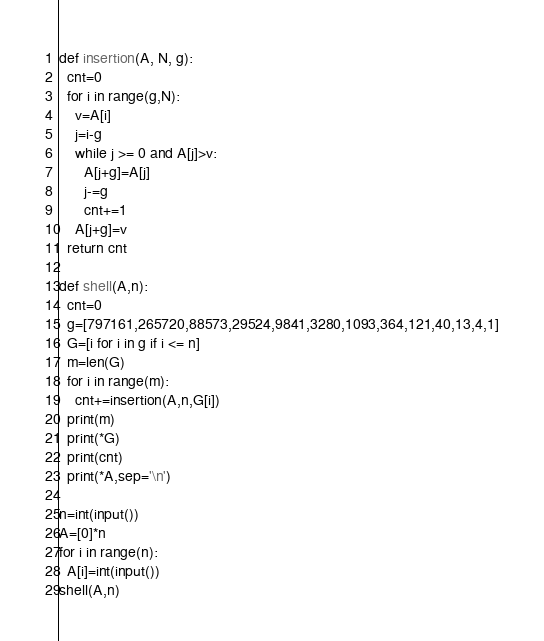Convert code to text. <code><loc_0><loc_0><loc_500><loc_500><_Python_>def insertion(A, N, g):
  cnt=0
  for i in range(g,N):
    v=A[i]
    j=i-g
    while j >= 0 and A[j]>v:
      A[j+g]=A[j]
      j-=g
      cnt+=1
    A[j+g]=v
  return cnt

def shell(A,n):
  cnt=0
  g=[797161,265720,88573,29524,9841,3280,1093,364,121,40,13,4,1]
  G=[i for i in g if i <= n]
  m=len(G)
  for i in range(m):
    cnt+=insertion(A,n,G[i])
  print(m)
  print(*G)
  print(cnt)
  print(*A,sep='\n')

n=int(input())
A=[0]*n
for i in range(n):
  A[i]=int(input())
shell(A,n)
</code> 